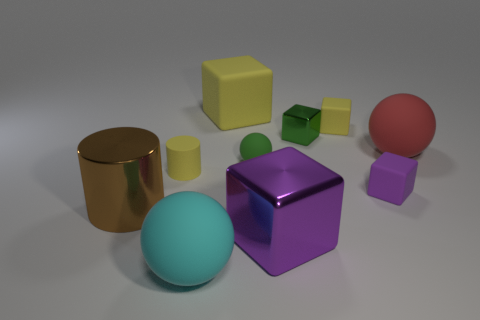What number of other things are there of the same size as the purple metallic block?
Keep it short and to the point. 4. What is the small object that is both right of the large yellow thing and on the left side of the big purple cube made of?
Provide a succinct answer. Rubber. Does the large metallic thing that is behind the purple metal thing have the same shape as the yellow rubber thing in front of the green shiny object?
Offer a very short reply. Yes. Are there any other things that have the same material as the small sphere?
Ensure brevity in your answer.  Yes. What is the shape of the big brown metal object that is in front of the yellow thing that is on the left side of the big yellow matte block behind the big brown shiny cylinder?
Offer a very short reply. Cylinder. How many other objects are there of the same shape as the green metal object?
Your answer should be very brief. 4. There is a sphere that is the same size as the yellow cylinder; what is its color?
Offer a terse response. Green. What number of cylinders are either big yellow things or small purple rubber things?
Ensure brevity in your answer.  0. What number of large red balls are there?
Keep it short and to the point. 1. Does the purple metallic object have the same shape as the tiny yellow thing behind the red rubber thing?
Ensure brevity in your answer.  Yes. 